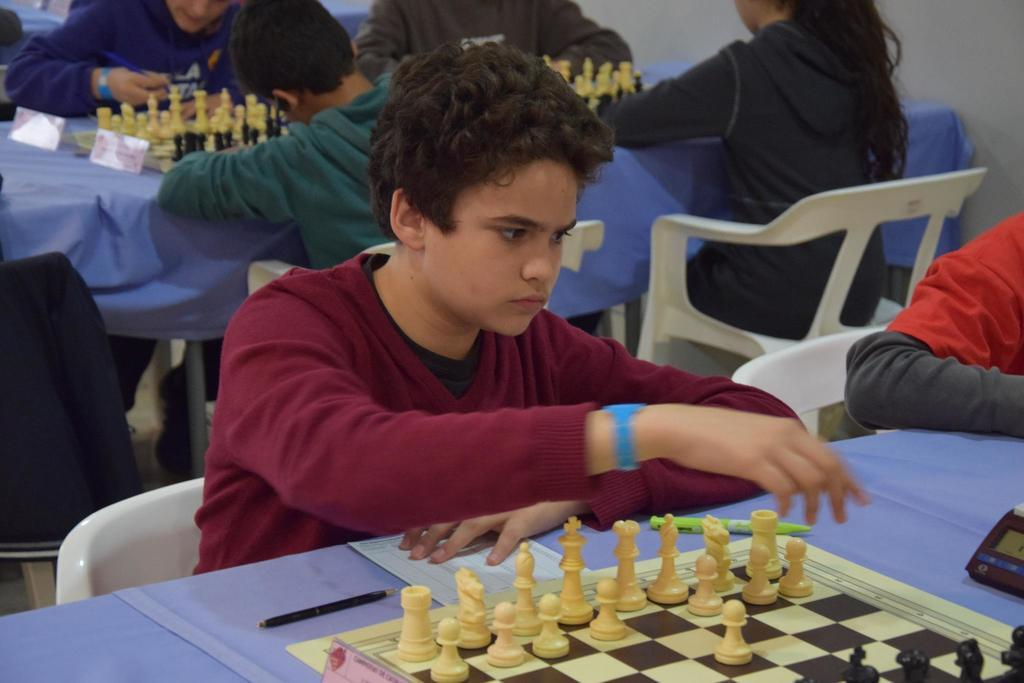What are the people in the image doing? People are sitting on chairs in the image. What objects are in front of the chairs? There are tables in front of the chairs. What activity is being performed on the tables? There are chess boards on the tables, and chess pieces are present on the chess boards. What writing instruments are visible on the tables? Pens are visible on the tables. What else is present on the tables? There is paper on the tables, as well as a board and a device. How many pencils are visible on the tables in the image? There are no pencils visible on the tables in the image. What number is written on the chess board in the image? There are no numbers written on the chess board in the image; it is a game board with alternating light and dark squares. 